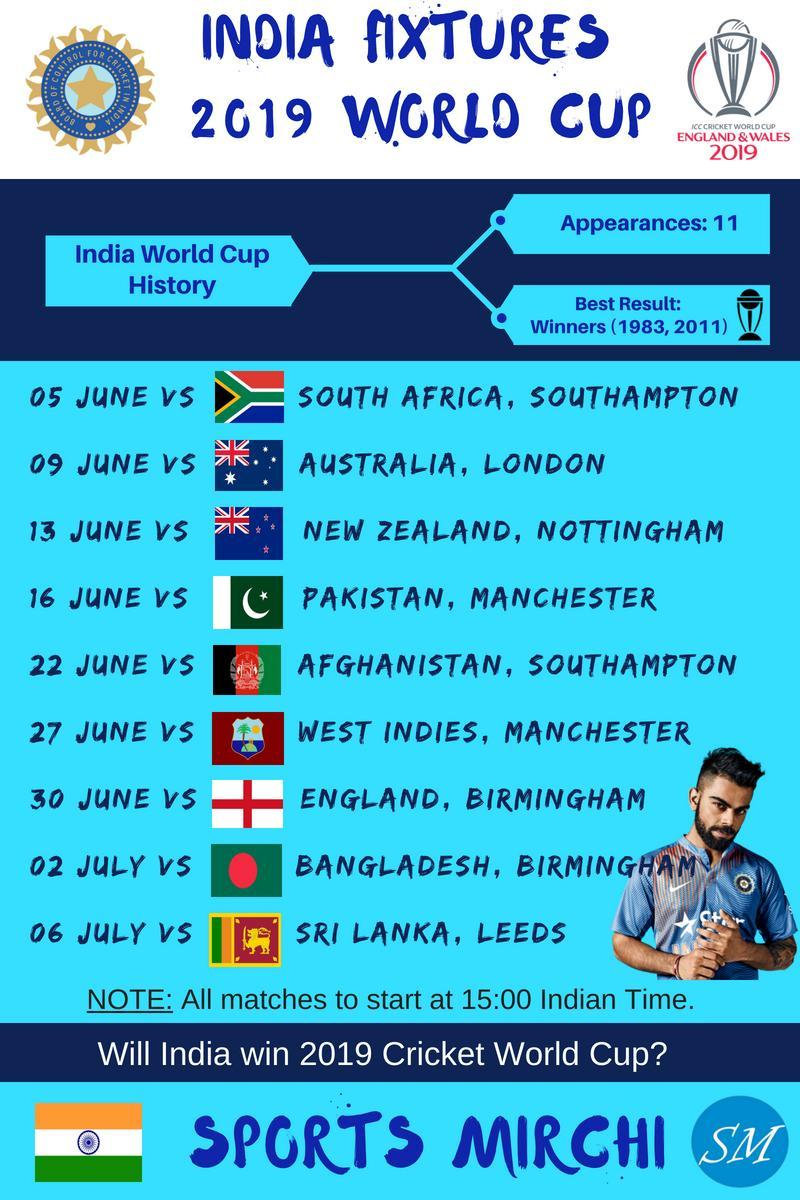How many times did India win the world cup?
Answer the question with a short phrase. 2 In which year India won their last world cup? 2011 In which year India won their first world cup? 1983 